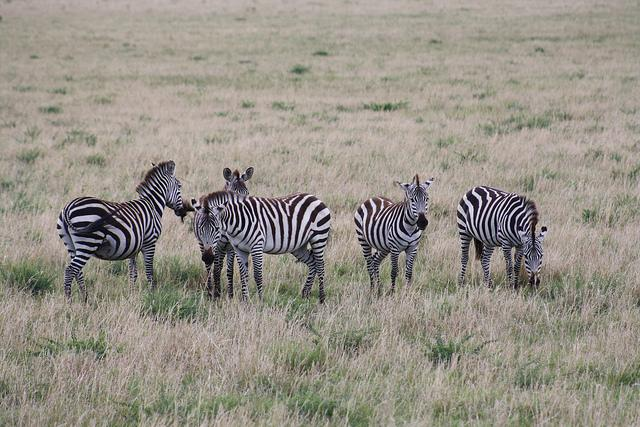How many zebras are standing in the middle of the open field? Please explain your reasoning. five. There are five zebras standing together and grazing in the open field. 